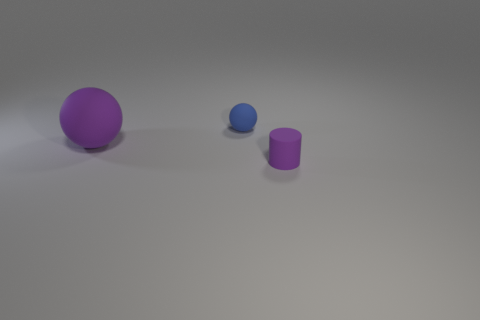Subtract all blue balls. How many balls are left? 1 Add 1 purple rubber spheres. How many objects exist? 4 Subtract 2 balls. How many balls are left? 0 Subtract all cylinders. How many objects are left? 2 Subtract all gray cylinders. Subtract all gray blocks. How many cylinders are left? 1 Subtract all brown cylinders. How many yellow balls are left? 0 Subtract all big cyan matte blocks. Subtract all tiny purple rubber things. How many objects are left? 2 Add 3 tiny spheres. How many tiny spheres are left? 4 Add 1 purple cylinders. How many purple cylinders exist? 2 Subtract 1 purple cylinders. How many objects are left? 2 